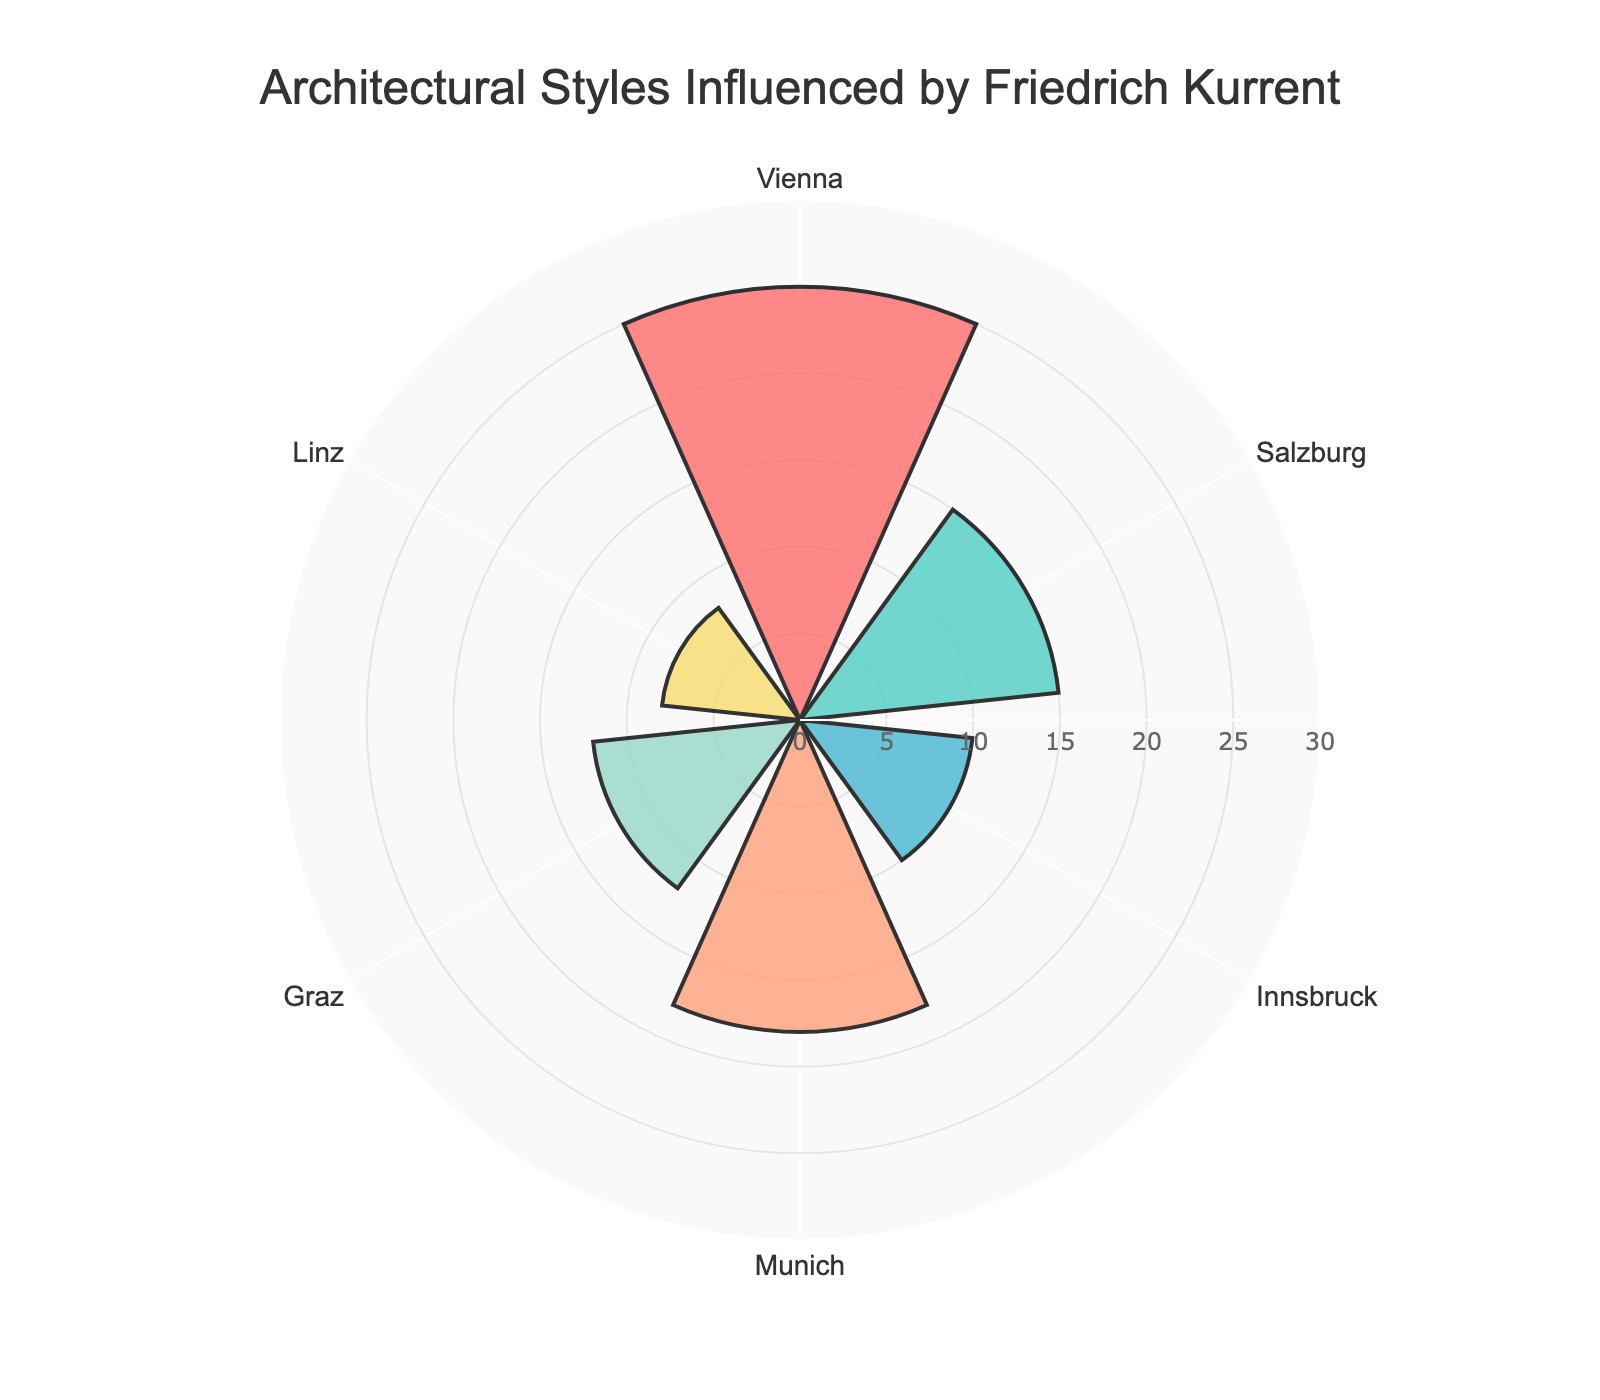What's the city with the highest number of buildings influenced by Friedrich Kurrent? The figure shows that Vienna has the longest bar in the polar area chart, indicating it has the highest number of buildings.
Answer: Vienna What is the title of the polar area chart? The title is shown at the top of the figure and reads "Architectural Styles Influenced by Friedrich Kurrent."
Answer: Architectural Styles Influenced by Friedrich Kurrent How many architectural styles are represented in the chart? By counting the number of distinct architectural style annotations in the figure, we find there are six different styles.
Answer: 6 Which city has fewer buildings influenced by Friedrich Kurrent, Innsbruck or Linz? By examining the lengths of the bars for Innsbruck and Linz, Linz has a shorter bar, indicating it has fewer buildings.
Answer: Linz What is the total number of buildings influenced by Friedrich Kurrent in Munich and Graz combined? Munich has 18 buildings and Graz has 12 buildings. Adding these together, 18 + 12, gives a total of 30 buildings.
Answer: 30 How does the number of buildings in Vienna compare to those in Linz? Vienna has 25 buildings while Linz has 8. 25 is greater than 8, so Vienna has more buildings than Linz.
Answer: Vienna has more Which city has the most minimalistic buildings influenced by Friedrich Kurrent and how many? By looking at the annotation and corresponding bar for Minimalism, Munich has the most minimalistic buildings with 18.
Answer: Munich, 18 What is the average number of buildings per city influenced by Friedrich Kurrent? Summing the number of buildings for all cities: 25 (Vienna) + 15 (Salzburg) + 10 (Innsbruck) + 18 (Munich) + 12 (Graz) + 8 (Linz) = 88. Dividing by the number of cities, 88 / 6 = approximately 14.67.
Answer: 14.67 What is the second highest number of buildings in any one city influenced by Friedrich Kurrent? First, note the numbers of buildings for all cities: 25 (Vienna), 15 (Salzburg), 10 (Innsbruck), 18 (Munich), 12 (Graz), 8 (Linz). The second highest value is 18.
Answer: 18 Is there any city with fewer than 10 buildings influenced by Friedrich Kurrent? If yes, name it. Linz has 8 buildings influenced by Friedrich Kurrent, which is fewer than 10.
Answer: Linz 